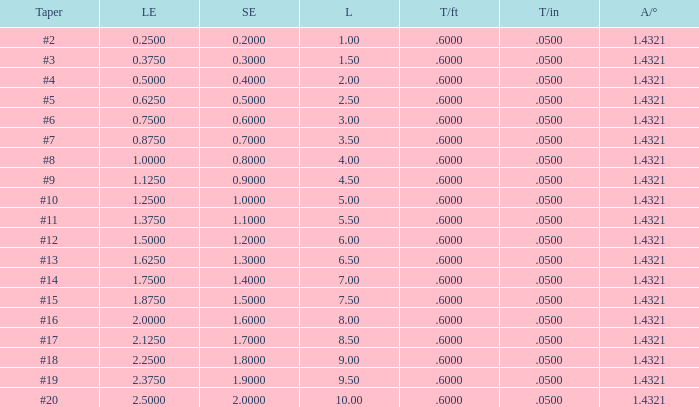Which Taper/ft that has a Large end smaller than 0.5, and a Taper of #2? 0.6. 